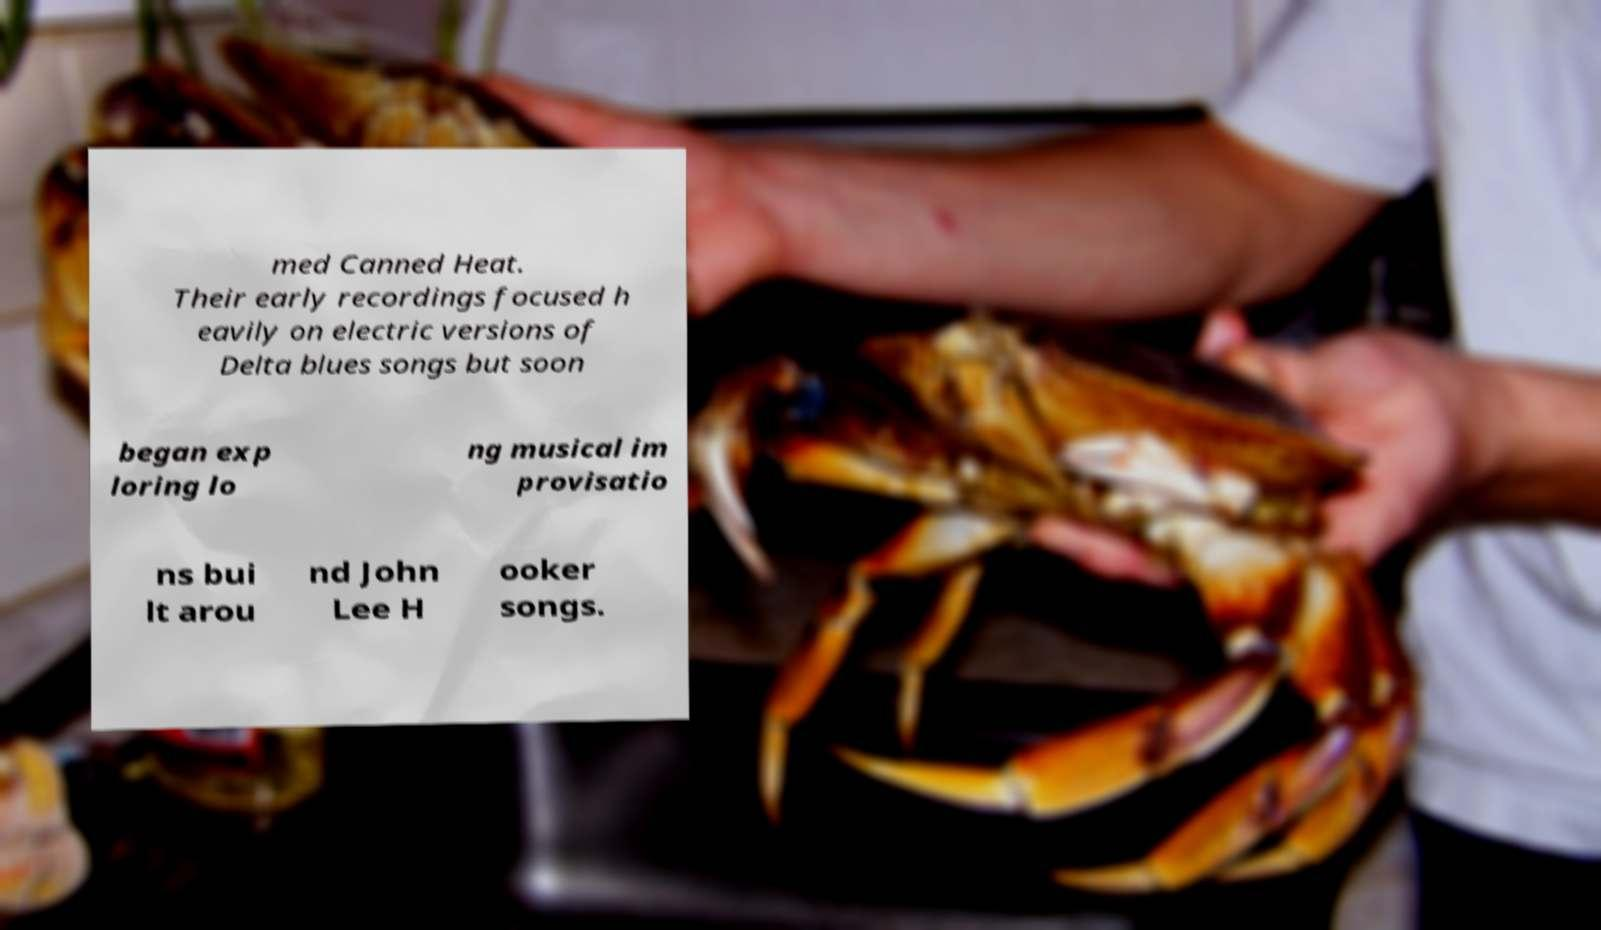Could you assist in decoding the text presented in this image and type it out clearly? med Canned Heat. Their early recordings focused h eavily on electric versions of Delta blues songs but soon began exp loring lo ng musical im provisatio ns bui lt arou nd John Lee H ooker songs. 